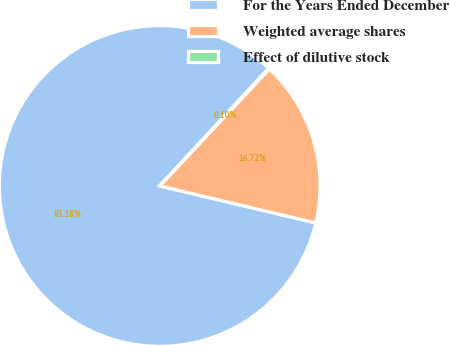<chart> <loc_0><loc_0><loc_500><loc_500><pie_chart><fcel>For the Years Ended December<fcel>Weighted average shares<fcel>Effect of dilutive stock<nl><fcel>83.18%<fcel>16.72%<fcel>0.1%<nl></chart> 